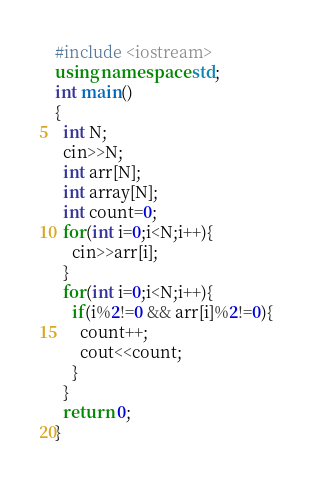<code> <loc_0><loc_0><loc_500><loc_500><_C++_>#include <iostream>
using namespace std;
int main()
{
  int N;
  cin>>N;
  int arr[N];
  int array[N];
  int count=0;
  for(int i=0;i<N;i++){
    cin>>arr[i];
  }
  for(int i=0;i<N;i++){
    if(i%2!=0 && arr[i]%2!=0){
      count++;
      cout<<count;
    }
  }
  return 0;
}</code> 